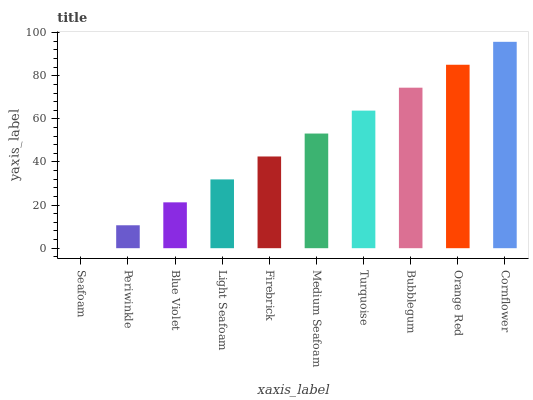Is Seafoam the minimum?
Answer yes or no. Yes. Is Cornflower the maximum?
Answer yes or no. Yes. Is Periwinkle the minimum?
Answer yes or no. No. Is Periwinkle the maximum?
Answer yes or no. No. Is Periwinkle greater than Seafoam?
Answer yes or no. Yes. Is Seafoam less than Periwinkle?
Answer yes or no. Yes. Is Seafoam greater than Periwinkle?
Answer yes or no. No. Is Periwinkle less than Seafoam?
Answer yes or no. No. Is Medium Seafoam the high median?
Answer yes or no. Yes. Is Firebrick the low median?
Answer yes or no. Yes. Is Orange Red the high median?
Answer yes or no. No. Is Seafoam the low median?
Answer yes or no. No. 